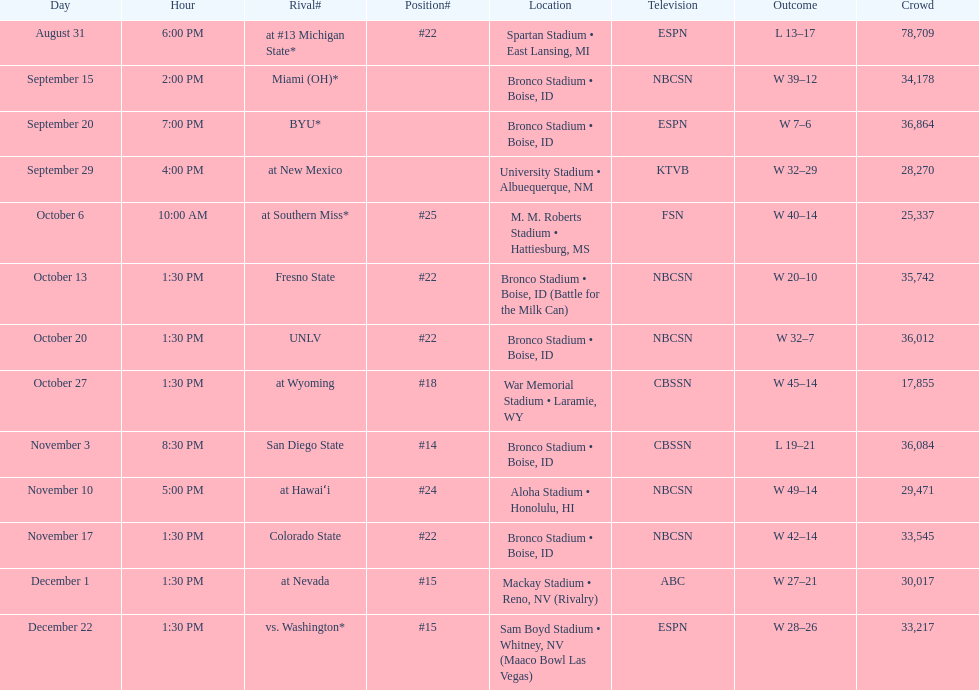What is the total number of games played at bronco stadium? 6. 